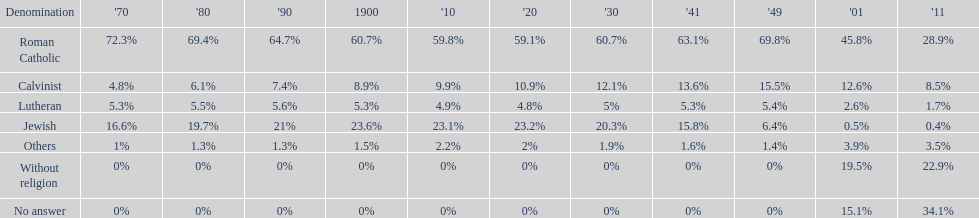The percentage of people who identified as calvinist was, at most, how much? 15.5%. Parse the table in full. {'header': ['Denomination', "'70", "'80", "'90", '1900', "'10", "'20", "'30", "'41", "'49", "'01", "'11"], 'rows': [['Roman Catholic', '72.3%', '69.4%', '64.7%', '60.7%', '59.8%', '59.1%', '60.7%', '63.1%', '69.8%', '45.8%', '28.9%'], ['Calvinist', '4.8%', '6.1%', '7.4%', '8.9%', '9.9%', '10.9%', '12.1%', '13.6%', '15.5%', '12.6%', '8.5%'], ['Lutheran', '5.3%', '5.5%', '5.6%', '5.3%', '4.9%', '4.8%', '5%', '5.3%', '5.4%', '2.6%', '1.7%'], ['Jewish', '16.6%', '19.7%', '21%', '23.6%', '23.1%', '23.2%', '20.3%', '15.8%', '6.4%', '0.5%', '0.4%'], ['Others', '1%', '1.3%', '1.3%', '1.5%', '2.2%', '2%', '1.9%', '1.6%', '1.4%', '3.9%', '3.5%'], ['Without religion', '0%', '0%', '0%', '0%', '0%', '0%', '0%', '0%', '0%', '19.5%', '22.9%'], ['No answer', '0%', '0%', '0%', '0%', '0%', '0%', '0%', '0%', '0%', '15.1%', '34.1%']]} 